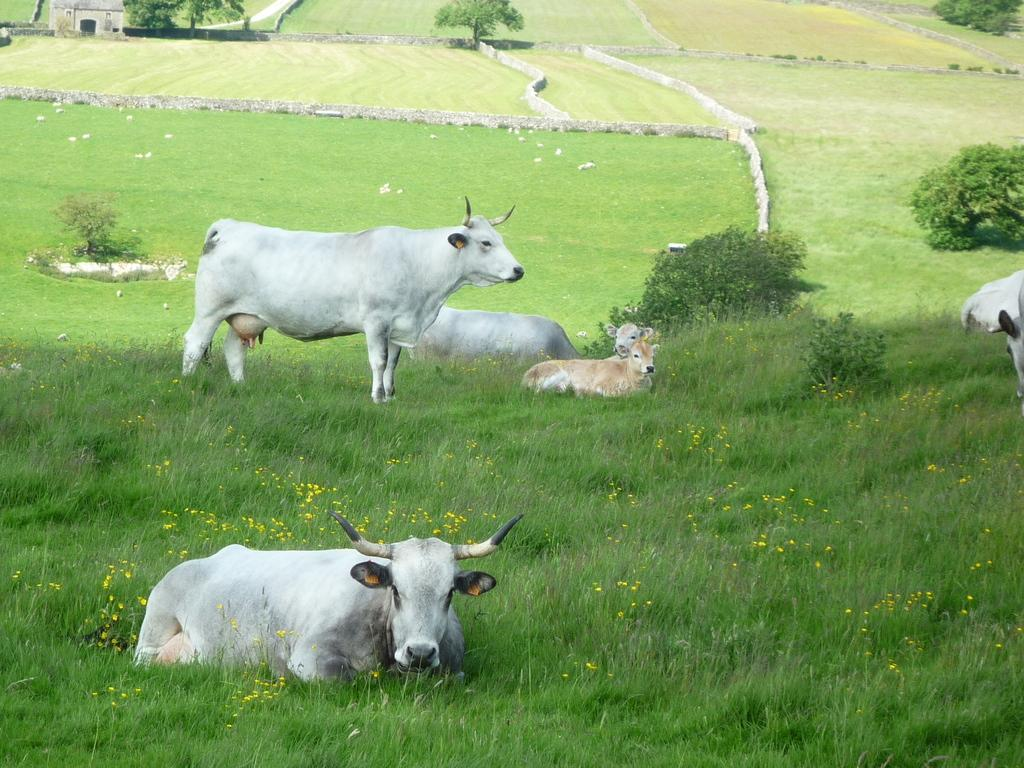What animals can be seen in the image? There are cows in the image. What type of vegetation is at the bottom of the image? There is grass at the bottom of the image. What else can be seen growing in the image? There are plants visible in the image. Where is the house located in the image? The house is in the left top part of the image. How many spiders are crawling on the cows in the image? There are no spiders visible in the image; it only features cows, grass, plants, and a house. 